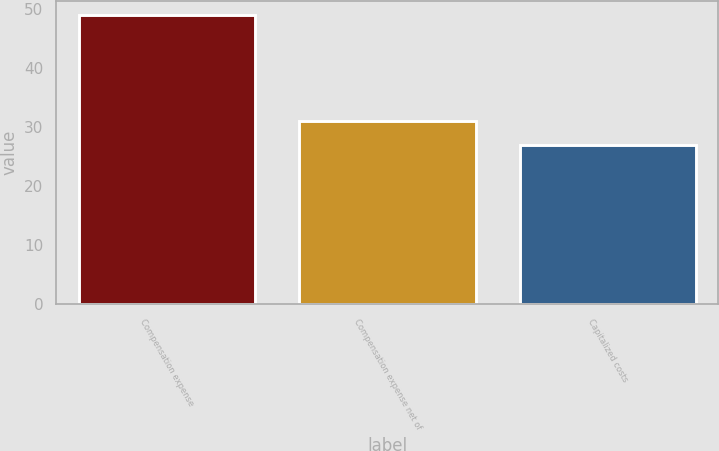<chart> <loc_0><loc_0><loc_500><loc_500><bar_chart><fcel>Compensation expense<fcel>Compensation expense net of<fcel>Capitalized costs<nl><fcel>49<fcel>31<fcel>27<nl></chart> 